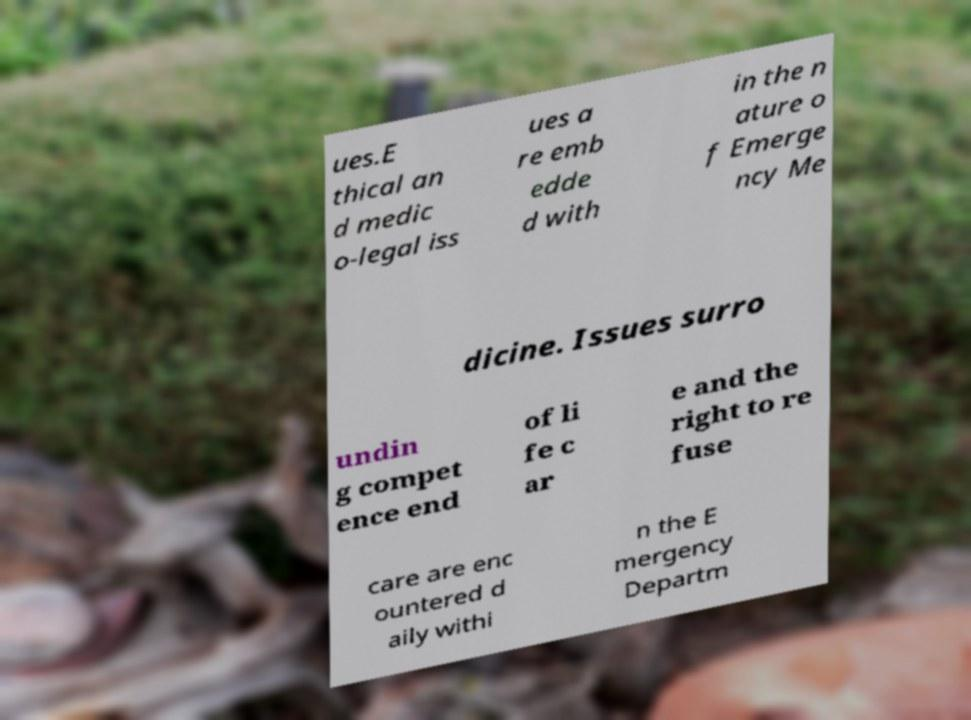Could you assist in decoding the text presented in this image and type it out clearly? ues.E thical an d medic o-legal iss ues a re emb edde d with in the n ature o f Emerge ncy Me dicine. Issues surro undin g compet ence end of li fe c ar e and the right to re fuse care are enc ountered d aily withi n the E mergency Departm 